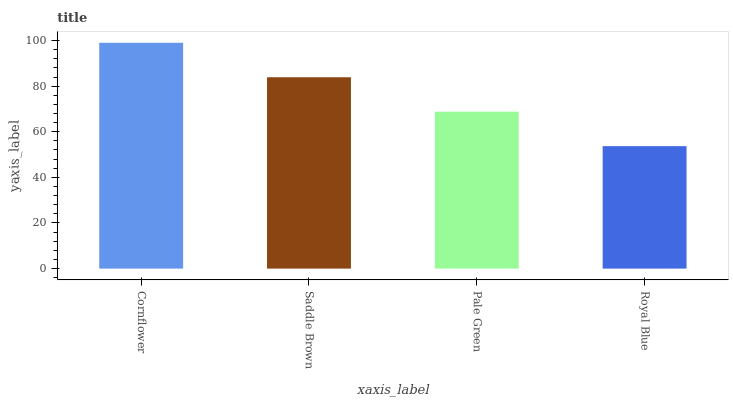Is Royal Blue the minimum?
Answer yes or no. Yes. Is Cornflower the maximum?
Answer yes or no. Yes. Is Saddle Brown the minimum?
Answer yes or no. No. Is Saddle Brown the maximum?
Answer yes or no. No. Is Cornflower greater than Saddle Brown?
Answer yes or no. Yes. Is Saddle Brown less than Cornflower?
Answer yes or no. Yes. Is Saddle Brown greater than Cornflower?
Answer yes or no. No. Is Cornflower less than Saddle Brown?
Answer yes or no. No. Is Saddle Brown the high median?
Answer yes or no. Yes. Is Pale Green the low median?
Answer yes or no. Yes. Is Pale Green the high median?
Answer yes or no. No. Is Royal Blue the low median?
Answer yes or no. No. 